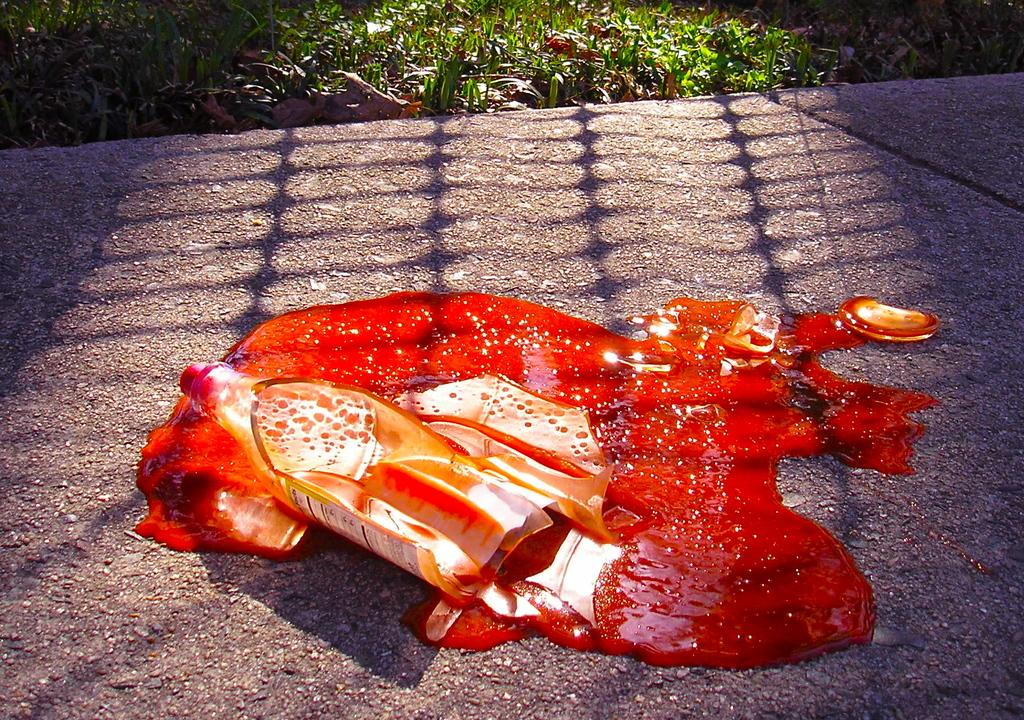What is the main object in the center of the image? There is a broken bottle in the center of the image. What is the condition of the liquid around the broken bottle? There is a liquid visible around the broken bottle. What type of natural environment can be seen in the background of the image? There is grass in the background of the image. What type of book is the laborer reading in the image? There is no laborer or book present in the image; it features a broken bottle and liquid in a grassy environment. 